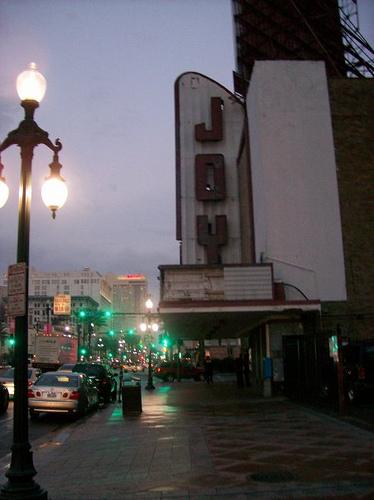What do the big letters spell?
Write a very short answer. Joy. Is it raining?
Quick response, please. No. Is there a building for rent?
Answer briefly. No. Is this an intersection?
Keep it brief. No. Is it day or nighttime?
Short answer required. Nighttime. Is joy the name of the town?
Keep it brief. No. Where was the picture taken of the vehicles and traffic signs?
Give a very brief answer. Street. Is this a busy street?
Keep it brief. Yes. Is it dawn or dusk?
Keep it brief. Dusk. 